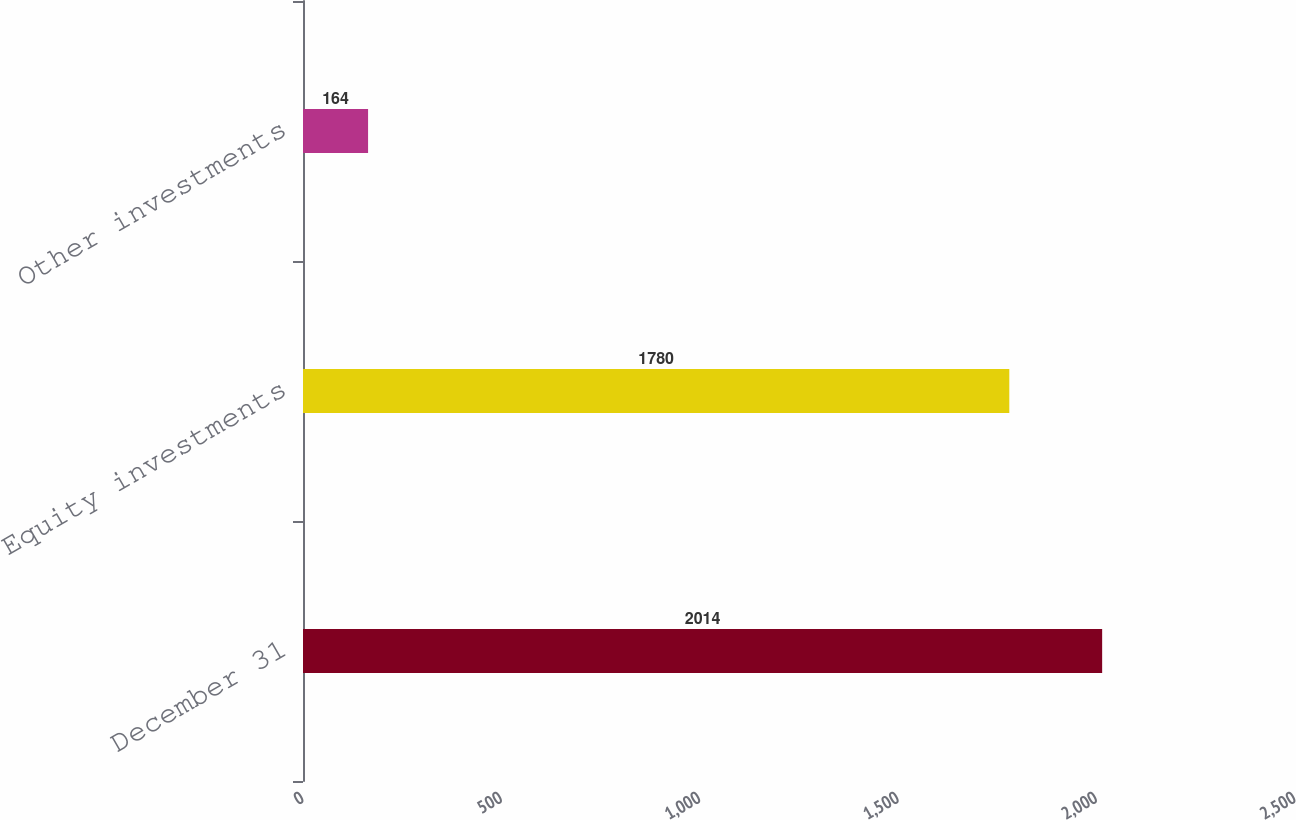Convert chart to OTSL. <chart><loc_0><loc_0><loc_500><loc_500><bar_chart><fcel>December 31<fcel>Equity investments<fcel>Other investments<nl><fcel>2014<fcel>1780<fcel>164<nl></chart> 